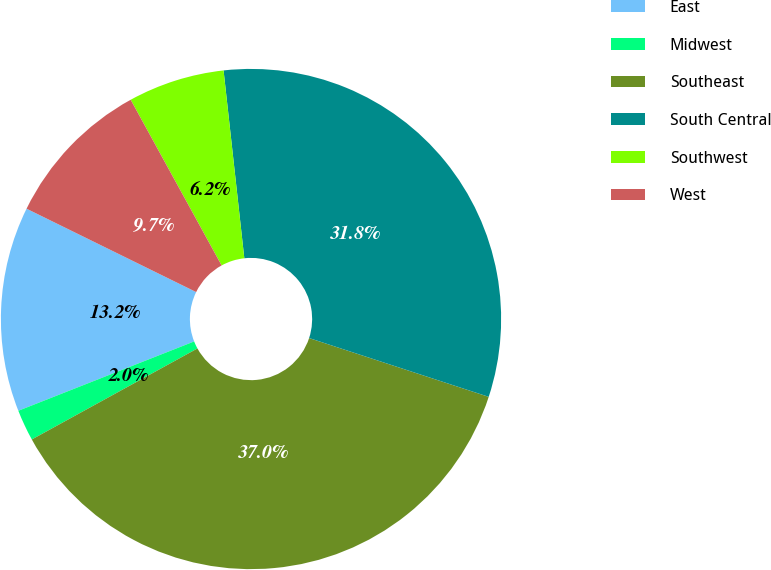<chart> <loc_0><loc_0><loc_500><loc_500><pie_chart><fcel>East<fcel>Midwest<fcel>Southeast<fcel>South Central<fcel>Southwest<fcel>West<nl><fcel>13.25%<fcel>2.02%<fcel>36.97%<fcel>31.79%<fcel>6.24%<fcel>9.74%<nl></chart> 